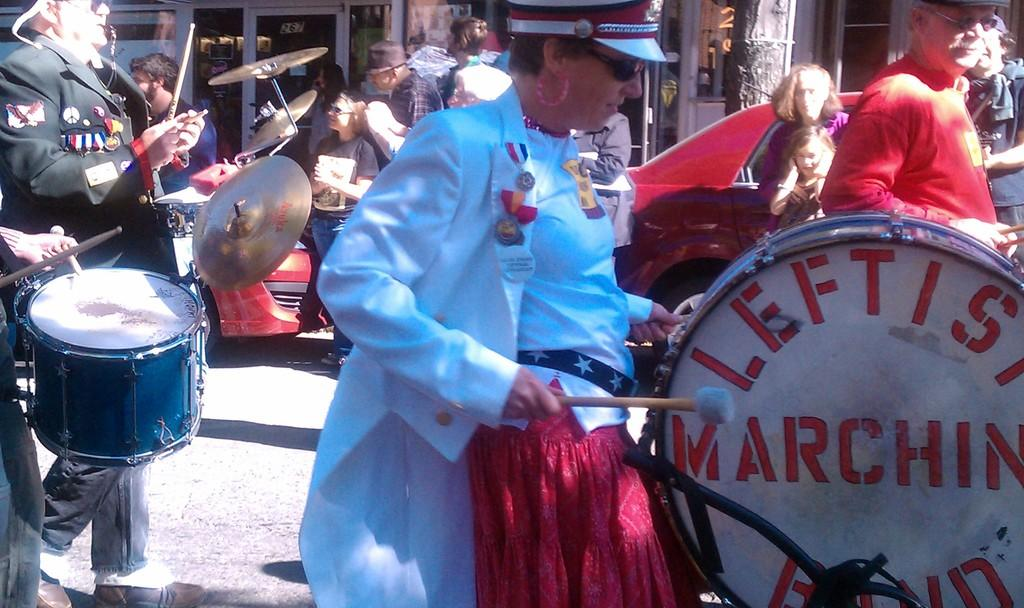What are the people in the image doing? The people in the image are playing musical instruments. Where are they playing? They are playing on the road. What else can be seen in the image besides the people playing instruments? There are vehicles and buildings visible in the image. What type of cable is being used by the musicians to enhance their performance in the image? There is no cable visible in the image, and the musicians are not using any cable to enhance their performance. 